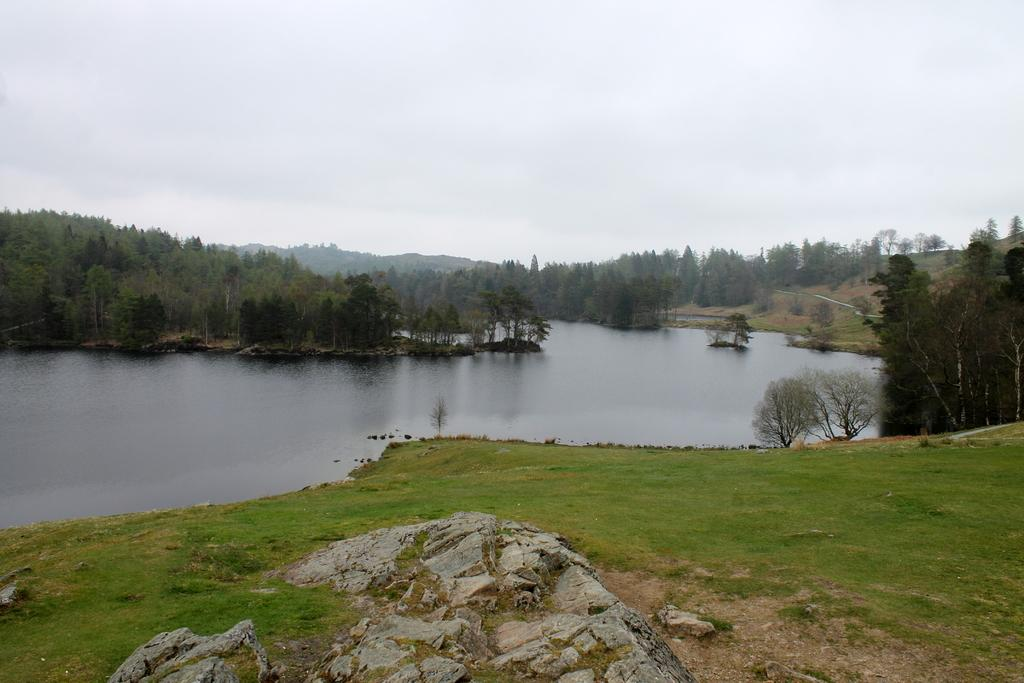What is in the foreground of the picture? There is grass and a rock in the foreground of the picture. What can be seen in the center of the picture? There are trees, hills, and a water body in the center of the picture. How would you describe the sky in the picture? The sky is cloudy in the picture. How does the grass help with digestion in the image? The grass in the image does not have any direct impact on digestion, as it is an inanimate object. Can you tell me which tree is the angriest in the image? Trees are not capable of expressing emotions like anger, so it is not possible to determine which tree might be the angriest in the image. 